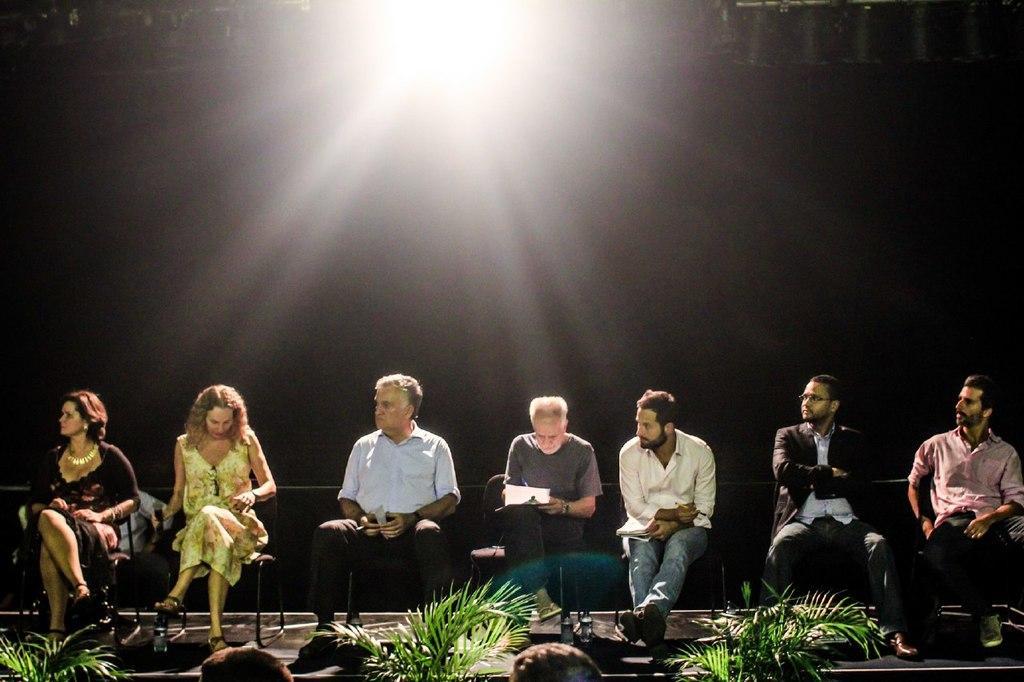Can you describe this image briefly? In this image there are few people sitting in the chair. At the top there is light. In front of them there are plants. In between the plants there are few people. 